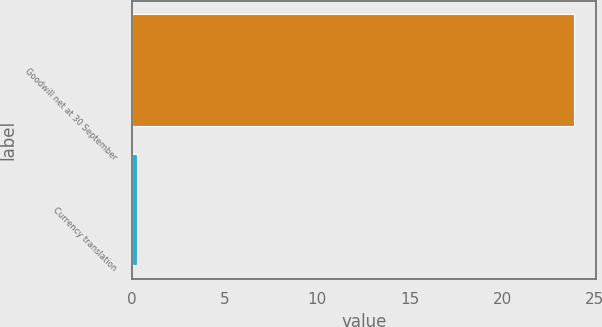Convert chart. <chart><loc_0><loc_0><loc_500><loc_500><bar_chart><fcel>Goodwill net at 30 September<fcel>Currency translation<nl><fcel>23.88<fcel>0.3<nl></chart> 